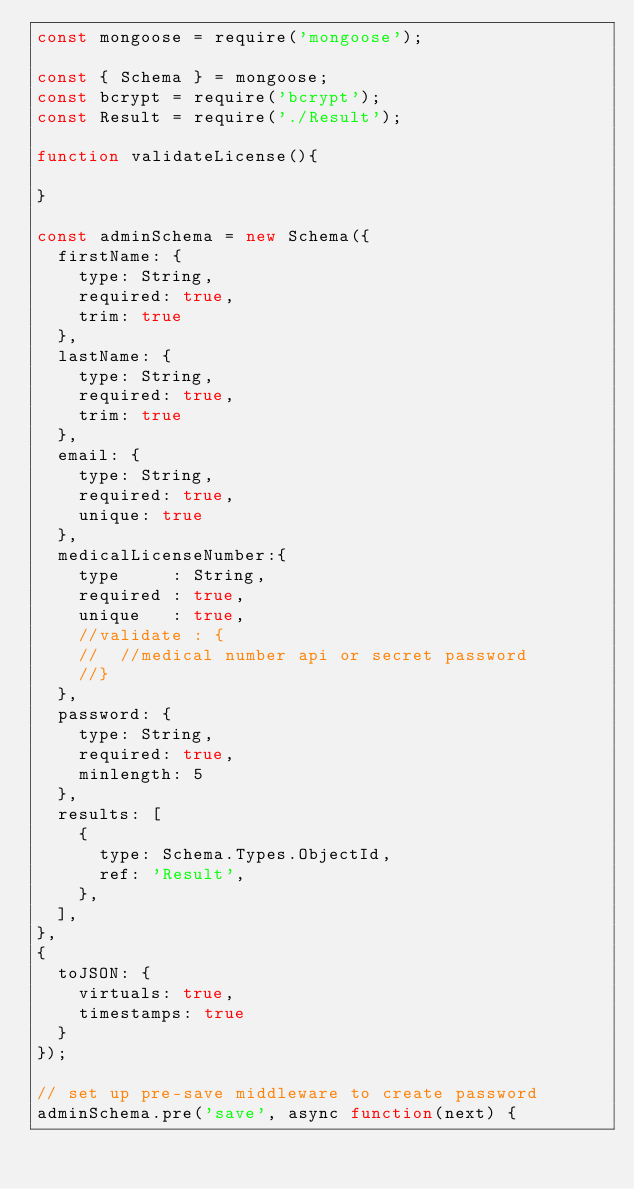Convert code to text. <code><loc_0><loc_0><loc_500><loc_500><_JavaScript_>const mongoose = require('mongoose');

const { Schema } = mongoose;
const bcrypt = require('bcrypt');
const Result = require('./Result');

function validateLicense(){

}

const adminSchema = new Schema({
  firstName: {
    type: String,
    required: true,
    trim: true
  },
  lastName: {
    type: String,
    required: true,
    trim: true
  },
  email: {
    type: String,
    required: true,
    unique: true
  },
  medicalLicenseNumber:{
    type     : String,
    required : true,
    unique   : true,
    //validate : {
    //  //medical number api or secret password
    //}
  },
  password: {
    type: String,
    required: true,
    minlength: 5
  },
  results: [
    {
      type: Schema.Types.ObjectId,
      ref: 'Result',
    },
  ],
},
{
  toJSON: {
    virtuals: true,
    timestamps: true
  }
});

// set up pre-save middleware to create password
adminSchema.pre('save', async function(next) {</code> 